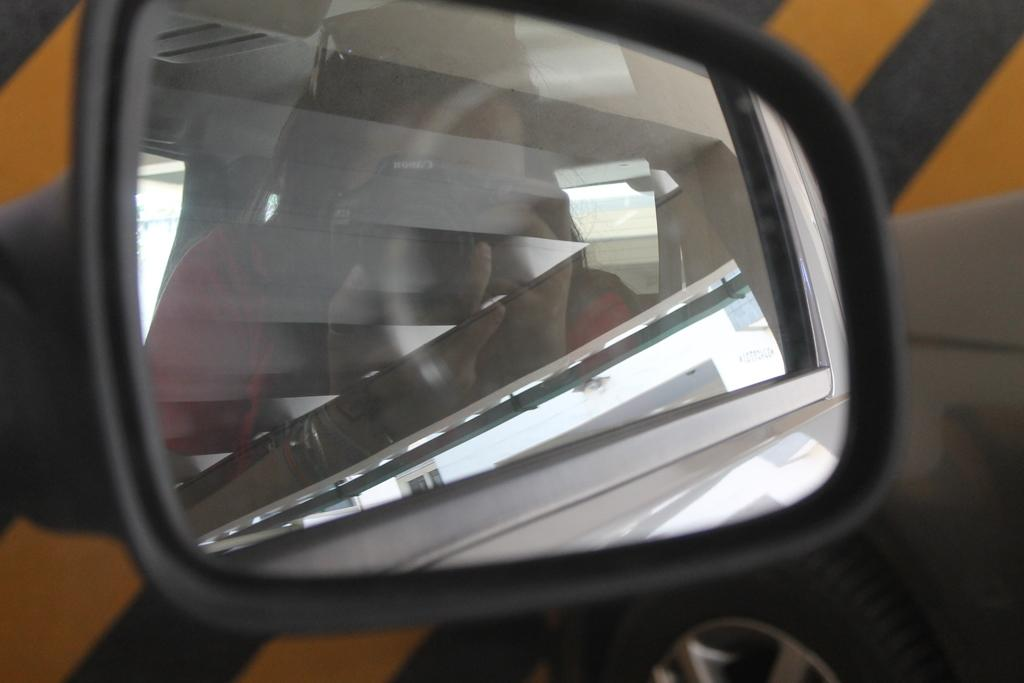What object is the main focus of the image? The main focus of the image is the side mirror of a car. What can be seen in the side mirror? There is a reflection of a woman in the side mirror. What is the woman doing in the image? The woman is taking a picture with a camera. What type of muscle is the woman exercising in the image? There is no indication of the woman exercising or displaying any muscles in the image. 